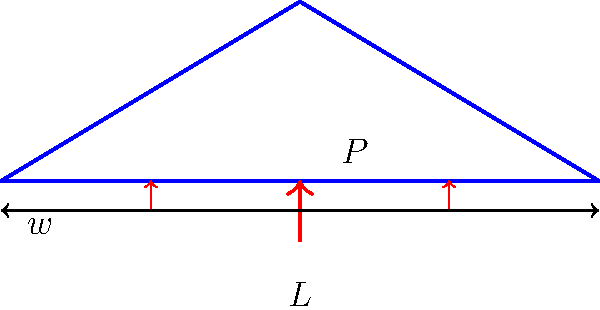In your VR environment, you've designed a simple truss bridge with a span of $L = 20$ meters. The bridge is subjected to a uniformly distributed load of $w = 5$ kN/m and a point load $P = 50$ kN at the center. Using virtual reality, you can visualize the stress distribution. Calculate the maximum bending moment $M_{max}$ in the bridge. Assume the bridge behaves as a simply supported beam. To calculate the maximum bending moment, we'll follow these steps:

1) First, calculate the total load on the bridge:
   Distributed load: $w \cdot L = 5 \text{ kN/m} \cdot 20 \text{ m} = 100 \text{ kN}$
   Point load: $P = 50 \text{ kN}$
   Total load: $100 \text{ kN} + 50 \text{ kN} = 150 \text{ kN}$

2) Calculate the reaction forces at the supports:
   Due to symmetry, each support bears half of the total load.
   $R_A = R_B = 150 \text{ kN} / 2 = 75 \text{ kN}$

3) The maximum bending moment occurs at the center of the beam where the point load is applied. It's the sum of moments due to the distributed load and the point load:

   a) Moment due to distributed load:
      $M_w = \frac{wL^2}{8} = \frac{5 \cdot 20^2}{8} = 250 \text{ kN}\cdot\text{m}$

   b) Moment due to point load:
      $M_P = \frac{PL}{4} = \frac{50 \cdot 20}{4} = 250 \text{ kN}\cdot\text{m}$

4) Total maximum bending moment:
   $M_{max} = M_w + M_P = 250 + 250 = 500 \text{ kN}\cdot\text{m}$

This calculation provides the maximum bending moment, which is crucial for assessing the bridge's structural integrity in your VR simulation.
Answer: $500 \text{ kN}\cdot\text{m}$ 